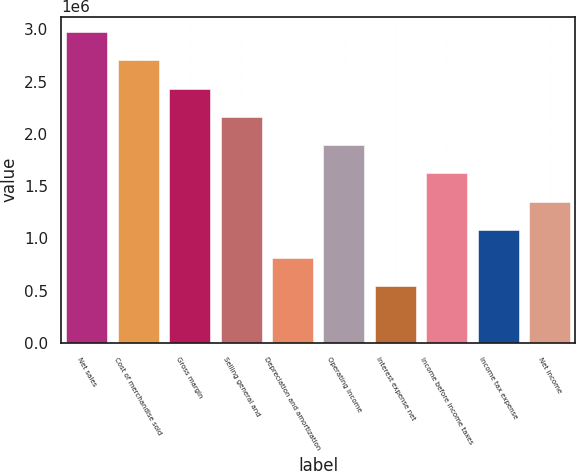<chart> <loc_0><loc_0><loc_500><loc_500><bar_chart><fcel>Net sales<fcel>Cost of merchandise sold<fcel>Gross margin<fcel>Selling general and<fcel>Depreciation and amortization<fcel>Operating income<fcel>Interest expense net<fcel>Income before income taxes<fcel>Income tax expense<fcel>Net income<nl><fcel>2.97353e+06<fcel>2.70321e+06<fcel>2.43289e+06<fcel>2.16257e+06<fcel>810965<fcel>1.89225e+06<fcel>540644<fcel>1.62193e+06<fcel>1.08129e+06<fcel>1.35161e+06<nl></chart> 